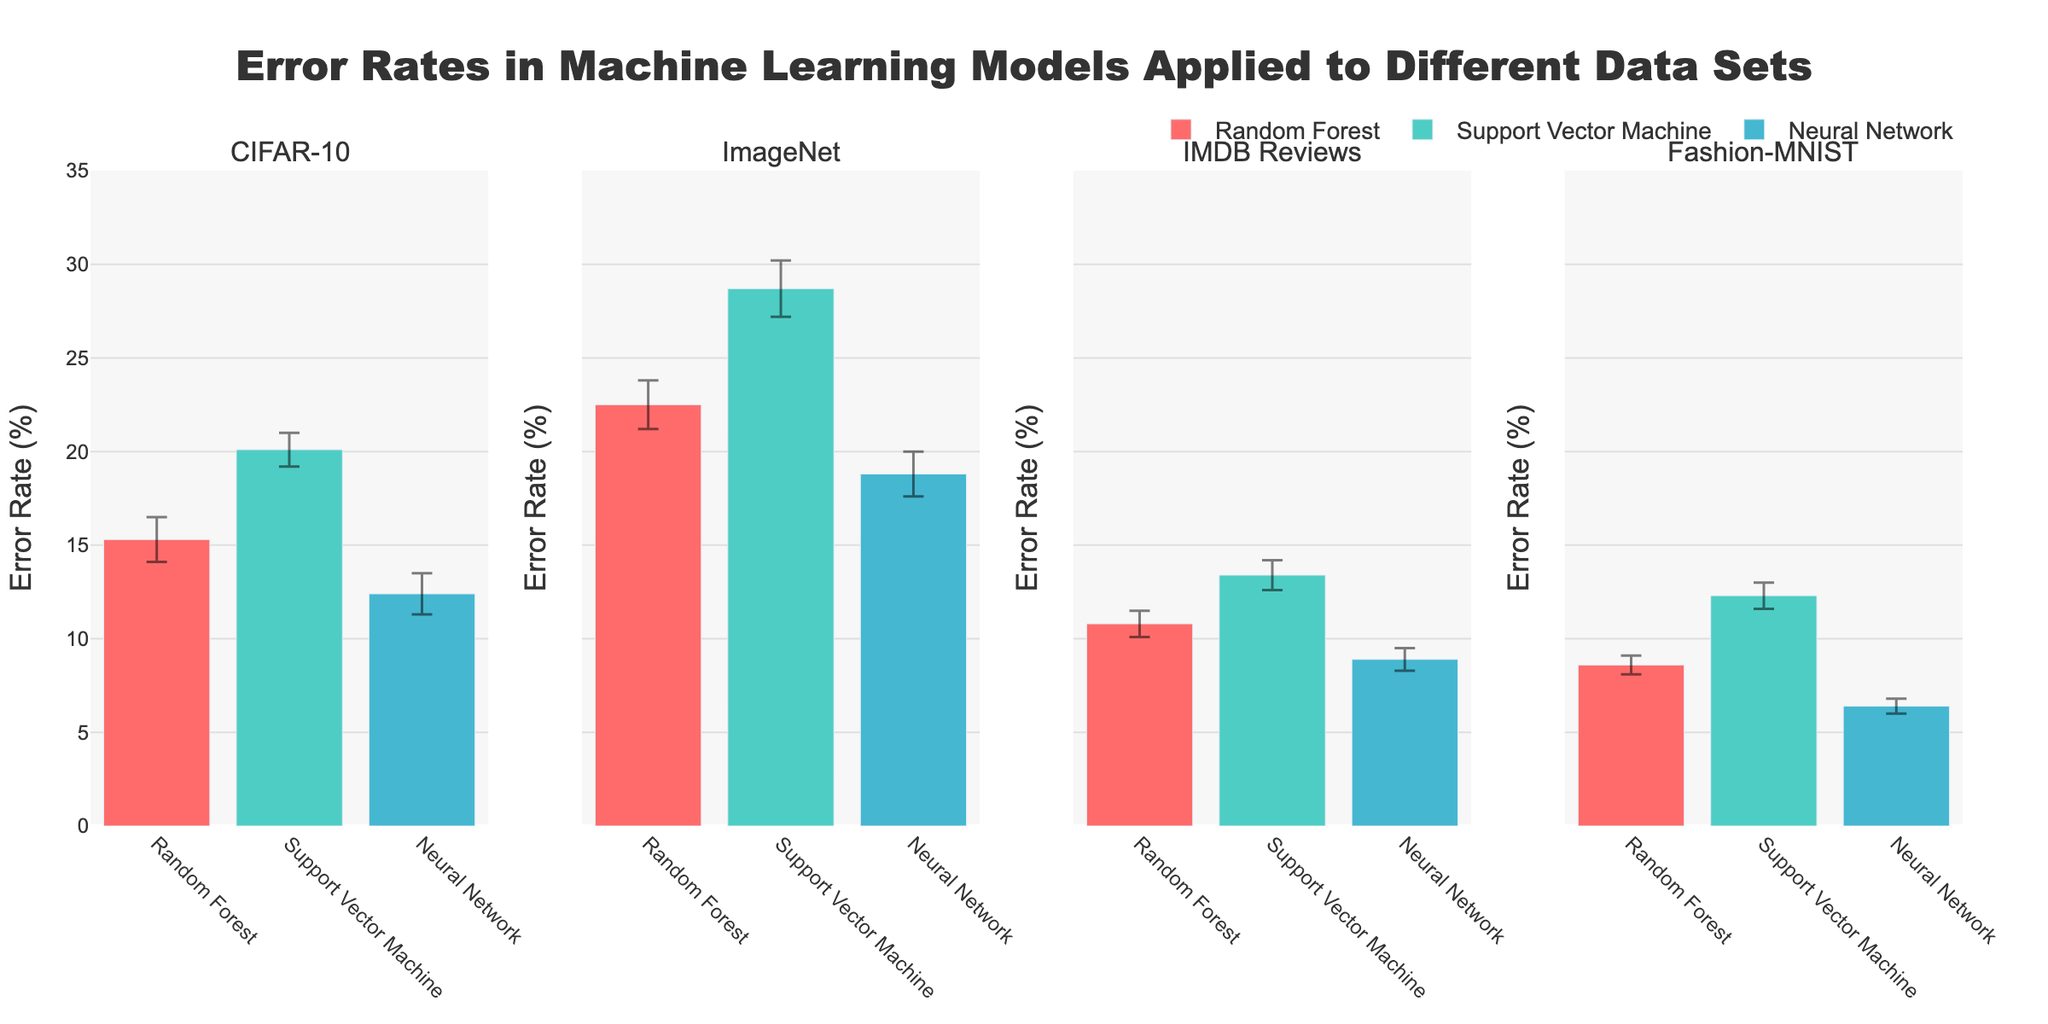what is the title of the figure? The title of the figure is generally located at the top center. By reading that section, you will find the text displayed.
Answer: Error Rates in Machine Learning Models Applied to Different Data Sets What is the average error rate for the Neural Network on ImageNet? Look at the bar corresponding to the Neural Network within the ImageNet subplot, which lists the average error rate.
Answer: 18.8% Which model has the highest average error rate on CIFAR-10? Compare the heights of the bars in the CIFAR-10 subplot for all models. The tallest bar corresponds to the model with the highest error rate.
Answer: Support Vector Machine Which model and data set combination has the lowest error rate? Check the height of all bars across all subplots and identify the shortest one, which shows the lowest error rate.
Answer: Neural Network on Fashion-MNIST By how much does the error rate of the Random Forest on CIFAR-10 differ from its error rate on ImageNet? Identify the error rates for Random Forest on both CIFAR-10 and ImageNet, then calculate the absolute difference.
Answer: 7.2% Which model shows the greatest variability in error rates across all data sets? For each model, look at the length of the error bars (standard deviation) across different data sets and determine which model has the longest error bars on average.
Answer: Support Vector Machine Between Random Forest and Neural Network, which model performs better on IMDB Reviews in terms of average error rate? Compare the height of the bars for Random Forest and Neural Network in the IMDB Reviews subplot. The model with the shorter bar performs better.
Answer: Neural Network What is the sum of average error rates for all models on Fashion-MNIST? Locate the average error rates for Random Forest, SVM, and Neural Network on Fashion-MNIST individually. Then sum these values: 8.6 + 12.3 + 6.4 = 27.3
Answer: 27.3% Does the Neural Network consistently have a lower error rate than the Support Vector Machine across all data sets? Compare the bars for Neural Network and Support Vector Machine in each subplot, checking if Neural Network's bar is always shorter.
Answer: Yes What is the average standard deviation across all models and data sets? Sum all the standard deviation values and divide by the number of entries. Calculation: (1.2 + 0.9 + 1.1 + 1.3 + 1.5 + 1.2 + 0.7 + 0.8 + 0.6 + 0.5 + 0.7 + 0.4) / 12 = 0.9
Answer: 0.9 